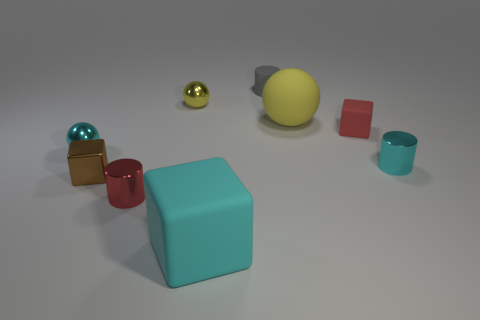What is the size of the brown cube? The brown cube appears to be small in comparison to the other objects in the scene, particularly when viewed next to the larger turquoise cube that dominates the foreground. 